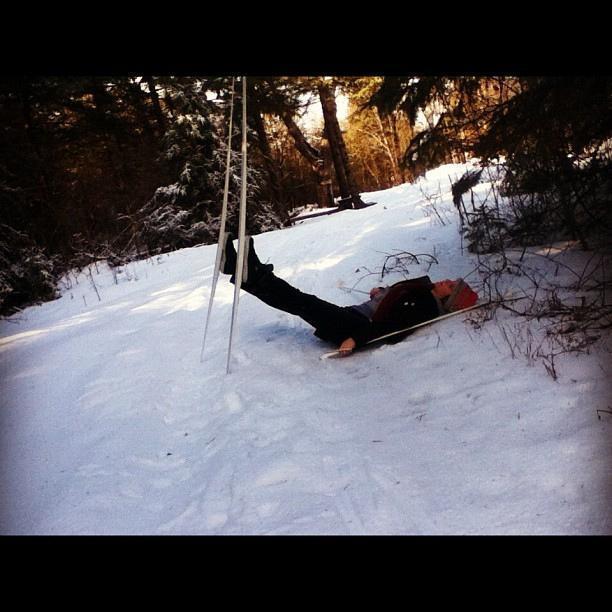How many people in the image?
Give a very brief answer. 1. How many cups are on the table?
Give a very brief answer. 0. 